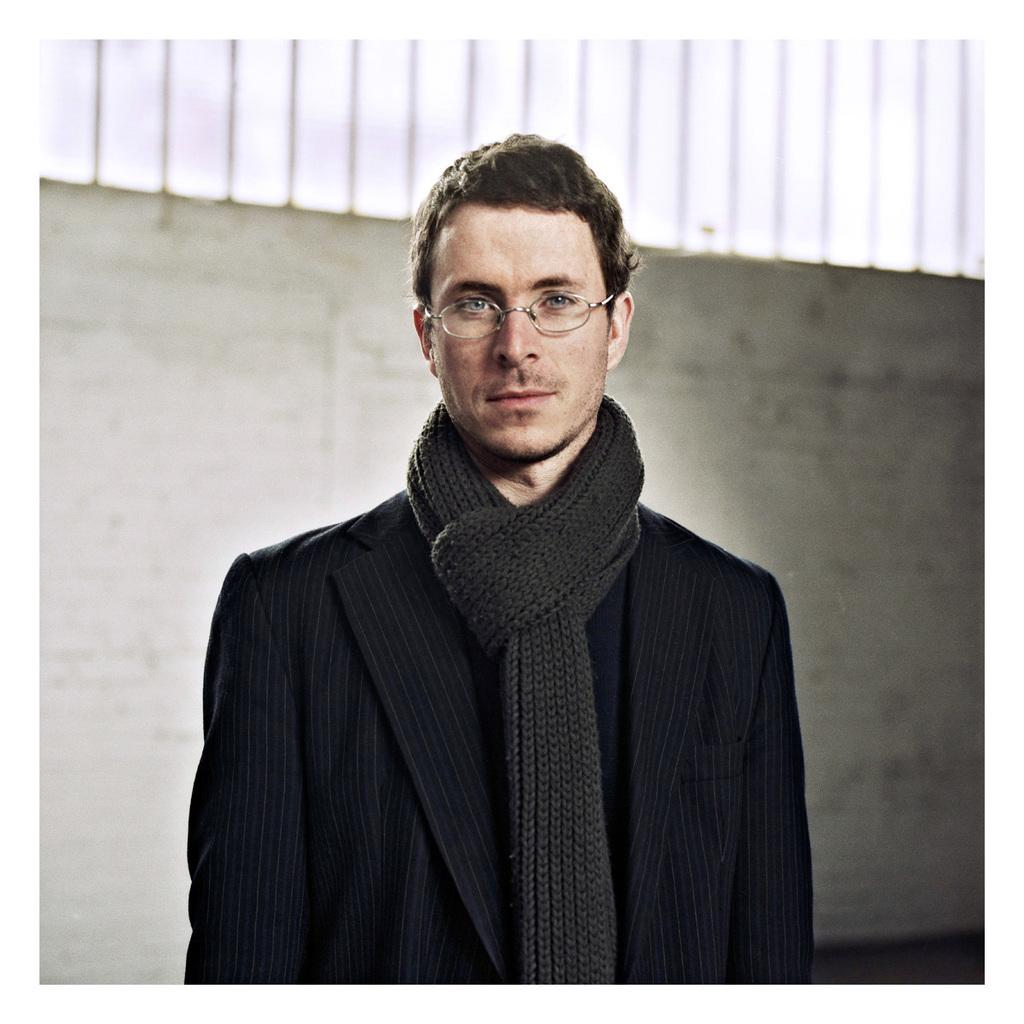What is the main subject of the image? There is a person standing in the image. What is the person wearing? The person is wearing a black dress. What can be seen in the background of the image? There is a wall and the sky visible in the background of the image. What color is the wall in the background? The wall is white. What color is the sky in the background? The sky is white. Can you see an island in the background of the image? There is no island present in the image; it only features a person, a wall, and the sky. What type of wrench is being used by the person in the image? There is no wrench visible in the image; the person is simply standing and wearing a black dress. 